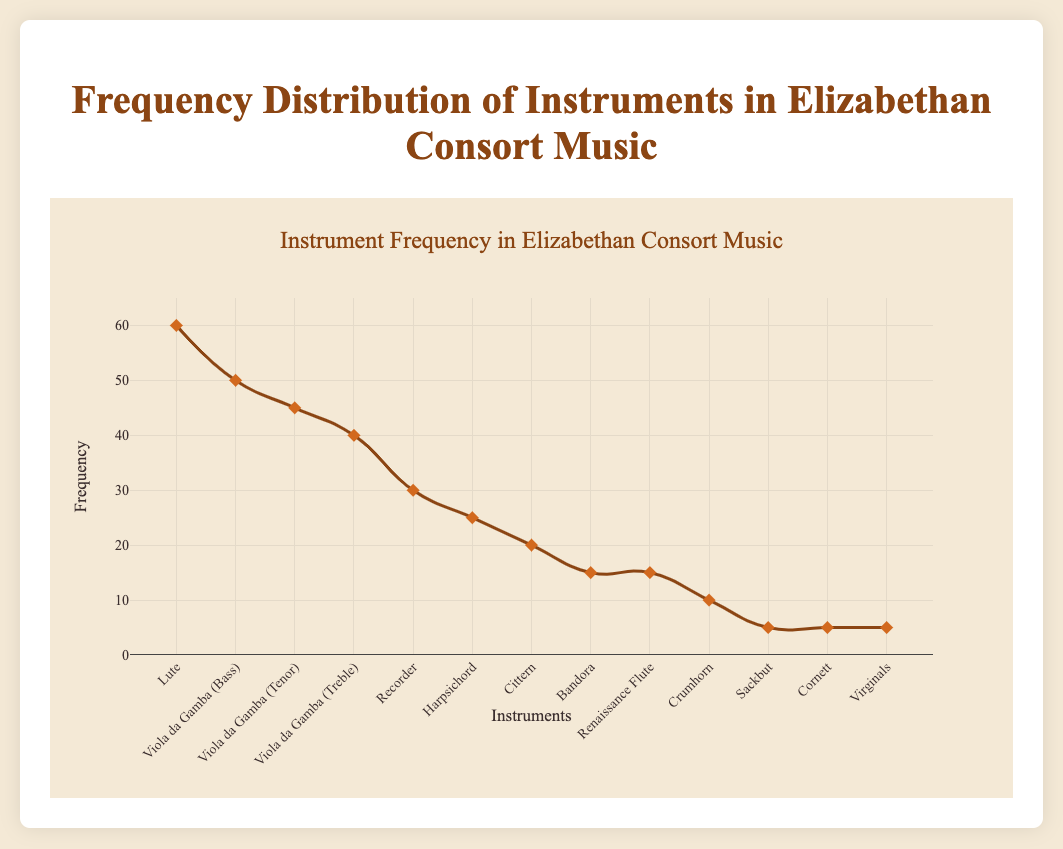What is the most frequently used instrument in Elizabethan Consort Music? The most frequently used instrument can be identified by looking at the highest point on the frequency curve. From the plot, the instrument with the highest frequency (60) is the Lute.
Answer: Lute Which instrument has a lower frequency, the Harpsichord or the Cittern? By comparing the data points for the Harpsichord (25) and the Cittern (20), we can see that the Cittern has a lower frequency.
Answer: Cittern What is the total frequency of all the Viola da Gamba instruments combined? To find the total frequency, sum the frequencies of the three Viola da Gamba instruments: Bass (50), Tenor (45), and Treble (40). 50 + 45 + 40 = 135.
Answer: 135 Which instruments share the same frequency? Look for data points on the plot that have the same height. The Sackbut, Cornett, and Virginals all have a frequency of 5. Also, the Bandora and Renaissance Flute both have a frequency of 15.
Answer: Sackbut, Cornett, Virginals, Bandora, Renaissance Flute What is the difference in frequency between the Recorder and the Harpsichord? Subtract the frequency of the Harpsichord (25) from the frequency of the Recorder (30). 30 - 25 = 5.
Answer: 5 What is the median frequency of the instruments? To find the median, list all frequencies in ascending order and find the middle value. The frequencies are: 5, 5, 5, 10, 15, 15, 20, 25, 30, 40, 45, 50, and 60. The middle value is 20.
Answer: 20 How many instruments have a frequency of at least 30? Count the number of instruments with a frequency of 30 or higher. These are: Lute (60), Viola da Gamba (Bass) (50), Viola da Gamba (Tenor) (45), Viola da Gamba (Treble) (40), and Recorder (30). There are 5 such instruments.
Answer: 5 Which has a higher frequency, the Crumhorn or the Renaissance Flute? Compare the frequency values of Crumhorn (10) and Renaissance Flute (15). The Renaissance Flute has a higher frequency.
Answer: Renaissance Flute 